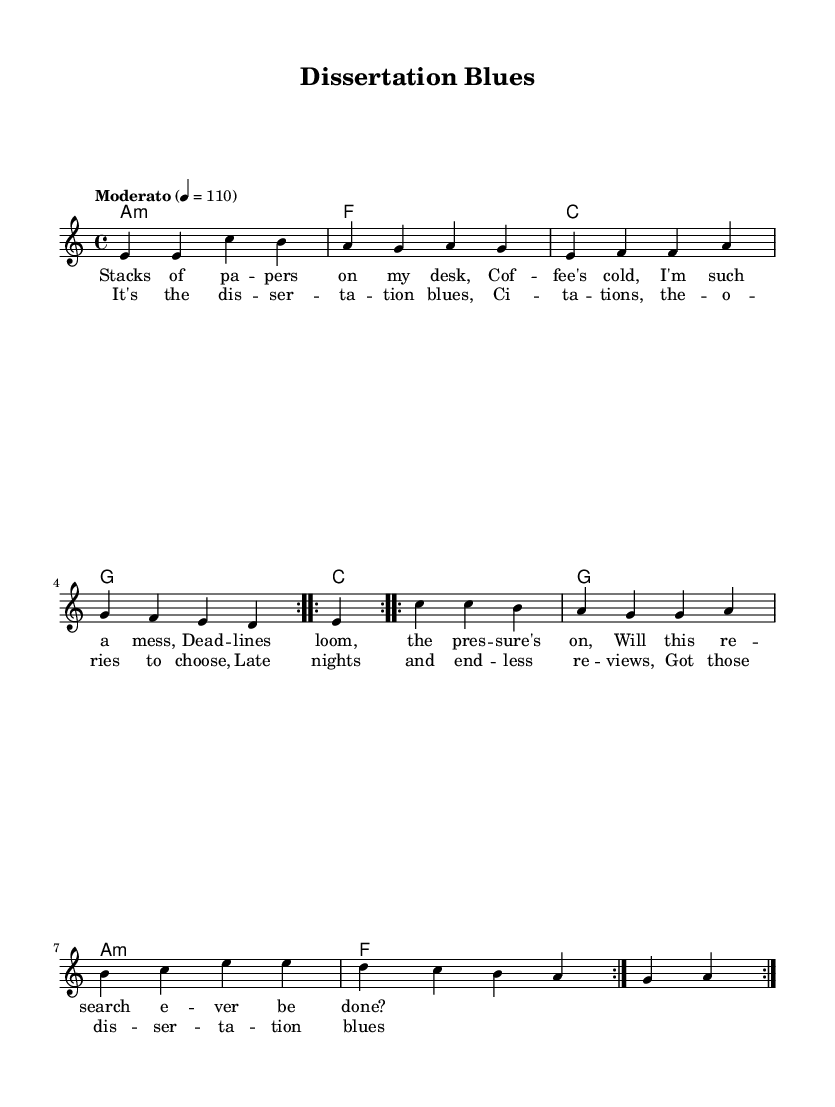What is the key signature of this music? The key signature is A minor, which is indicated by one sharp (G#). This is derived from the 'global' section where the key is specified.
Answer: A minor What is the time signature? The time signature is 4/4, which indicates four beats per measure. This is found in the 'global' section of the code.
Answer: 4/4 What is the tempo marking for this piece? The tempo marking indicates "Moderato" at quarter note equals 110 beats per minute. This is specified in the 'global' section.
Answer: Moderato 4 = 110 How many times is the melody repeated in the verses? The melody is repeated twice, as indicated by the \repeat volta 2 notation in the melody section.
Answer: 2 times How many measures are in the chorus of the song? The chorus consists of four lines of lyrics, each corresponding to one measure, totaling four measures. This can be analyzed from the structure of the lyrics provided.
Answer: 4 measures What type of lyrics are used in this song? The lyrics consist of a narrative exploring the struggles of academic life, specifically focusing on dissertation challenges. This is evident in the text provided under the 'verse' and 'chorus' sections, which highlight themes like pressure and late nights.
Answer: Narrative What is the primary theme of the song? The primary theme revolves around the struggles and challenges of completing a dissertation, as stated in the lyrics that evoke feelings of pressure and the difficulties faced in academic research.
Answer: Dissertation struggles 